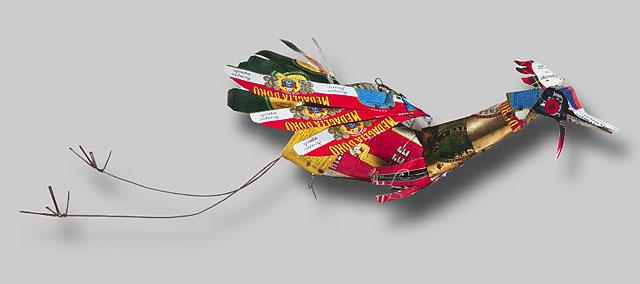What do you see happening in this image? This image displays a striking sculpture of a bird created from an array of repurposed objects, mainly colorful tin cans and bottle caps, illustrating a prime example of assemblage art. The body of the bird is skillfully formed from layers of red and green tin, while its wings showcase vibrant tones of blue and yellow. The bird's head is crafted with a mixture of red and blue colors from tin, and its eyes are represented by blue bottle caps, adding a charming expression to its appearance. The yellow bottle cap used as the beak provides a striking contrast, enhancing the bird's vivid and whimsical aesthetic. The legs of the bird are fashioned from thin, precise pieces of wire, showcasing the artist's intricate attention to detail, while its tail feathers are composed of a blend of green and yellow tin pieces, adding elegance to its structure. This sculptural piece not only reflects creativity in using everyday discarded items but also emphasizes sustainability in art. 